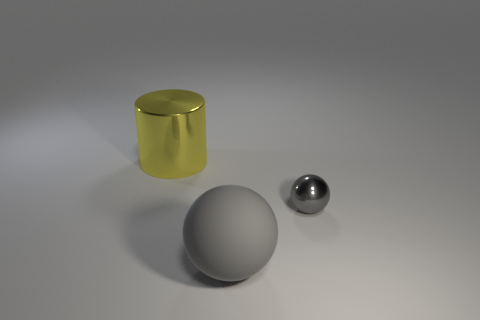There is a thing behind the tiny shiny sphere; what is it made of?
Make the answer very short. Metal. What is the color of the other thing that is the same shape as the tiny metallic thing?
Your answer should be compact. Gray. How many large rubber spheres are the same color as the tiny metallic ball?
Ensure brevity in your answer.  1. There is a thing that is to the left of the gray rubber object; is it the same size as the metal thing in front of the big yellow thing?
Make the answer very short. No. Do the gray rubber sphere and the metal object in front of the large shiny object have the same size?
Offer a very short reply. No. What size is the gray metallic sphere?
Your answer should be compact. Small. There is another thing that is made of the same material as the big yellow object; what color is it?
Ensure brevity in your answer.  Gray. How many small gray spheres have the same material as the yellow thing?
Offer a very short reply. 1. How many things are either big gray objects or objects that are to the right of the big yellow metal cylinder?
Your answer should be compact. 2. Are the thing that is behind the small gray shiny object and the tiny sphere made of the same material?
Offer a terse response. Yes. 